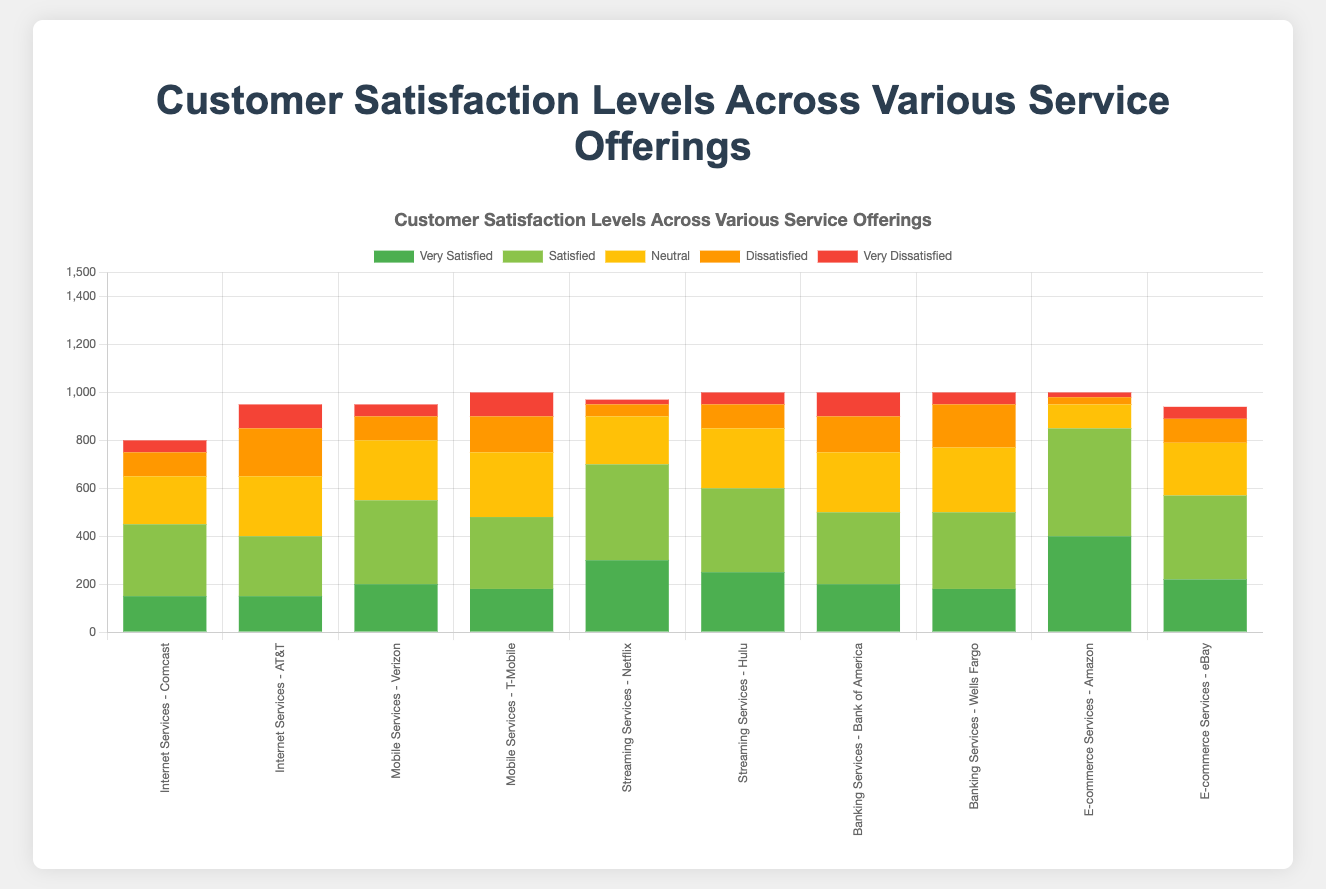How do the satisfaction levels of Comcast and AT&T for Internet Services compare? To compare the satisfaction levels, look at the values for "Very Satisfied" and "Satisfied" versus "Dissatisfied" and "Very Dissatisfied". Comcast has 150 Very Satisfied, 300 Satisfied, 100 Dissatisfied, and 50 Very Dissatisfied. AT&T has 150 Very Satisfied, 250 Satisfied, 200 Dissatisfied, and 100 Very Dissatisfied. Comcast has more Satisfied and fewer Dissatisfied customers.
Answer: Comcast has higher satisfaction levels Which provider has the highest number of Very Satisfied customers, and what service do they provide? To find this, look for the highest value in the "Very Satisfied" category across all providers. Amazon has the highest with 400 Very Satisfied customers. They provide E-commerce Services.
Answer: Amazon, E-commerce Services What's the total number of Neutral responses for Mobile Services? Add the Neutral responses for Verizon and T-Mobile. Verizon has 250 Neutral responses, and T-Mobile has 270 Neutral responses. Therefore, the total is 250 + 270 = 520.
Answer: 520 Which service offering has the lowest number of Very Dissatisfied customers and which provider offers it? Look for the lowest number in the "Very Dissatisfied" category across all service offerings. Netflix has the lowest with 20 Very Dissatisfied customers. They offer Streaming Services.
Answer: Streaming Services, Netflix Compare the total satisfaction levels (sum of Very Satisfied and Satisfied) for Banking Services between Bank of America and Wells Fargo. Which has higher total satisfaction? Bank of America has 200 Very Satisfied and 300 Satisfied, totaling 500. Wells Fargo has 180 Very Satisfied and 320 Satisfied, totaling 500. Both have equal total satisfaction levels.
Answer: Both have equal total satisfaction levels How does the height of the "Satisfied" section for Amazon compare to that for Netflix? The height of Amazon's "Satisfied" section is 450, while Netflix's "Satisfied" section is 400. Amazon's "Satisfied" section is taller.
Answer: Amazon's "Satisfied" section is taller Which provider in Internet Services has higher total Dissatisfied responses (sum of Dissatisfied and Very Dissatisfied)? For Comcast, Dissatisfied + Very Dissatisfied = 100 + 50 = 150. For AT&T, Dissatisfied + Very Dissatisfied = 200 + 100 = 300. AT&T has higher total Dissatisfied responses.
Answer: AT&T What's the difference in the number of Satisfied customers between T-Mobile and Hulu? T-Mobile has 300 Satisfied customers, and Hulu has 350. The difference is 350 - 300 = 50.
Answer: 50 